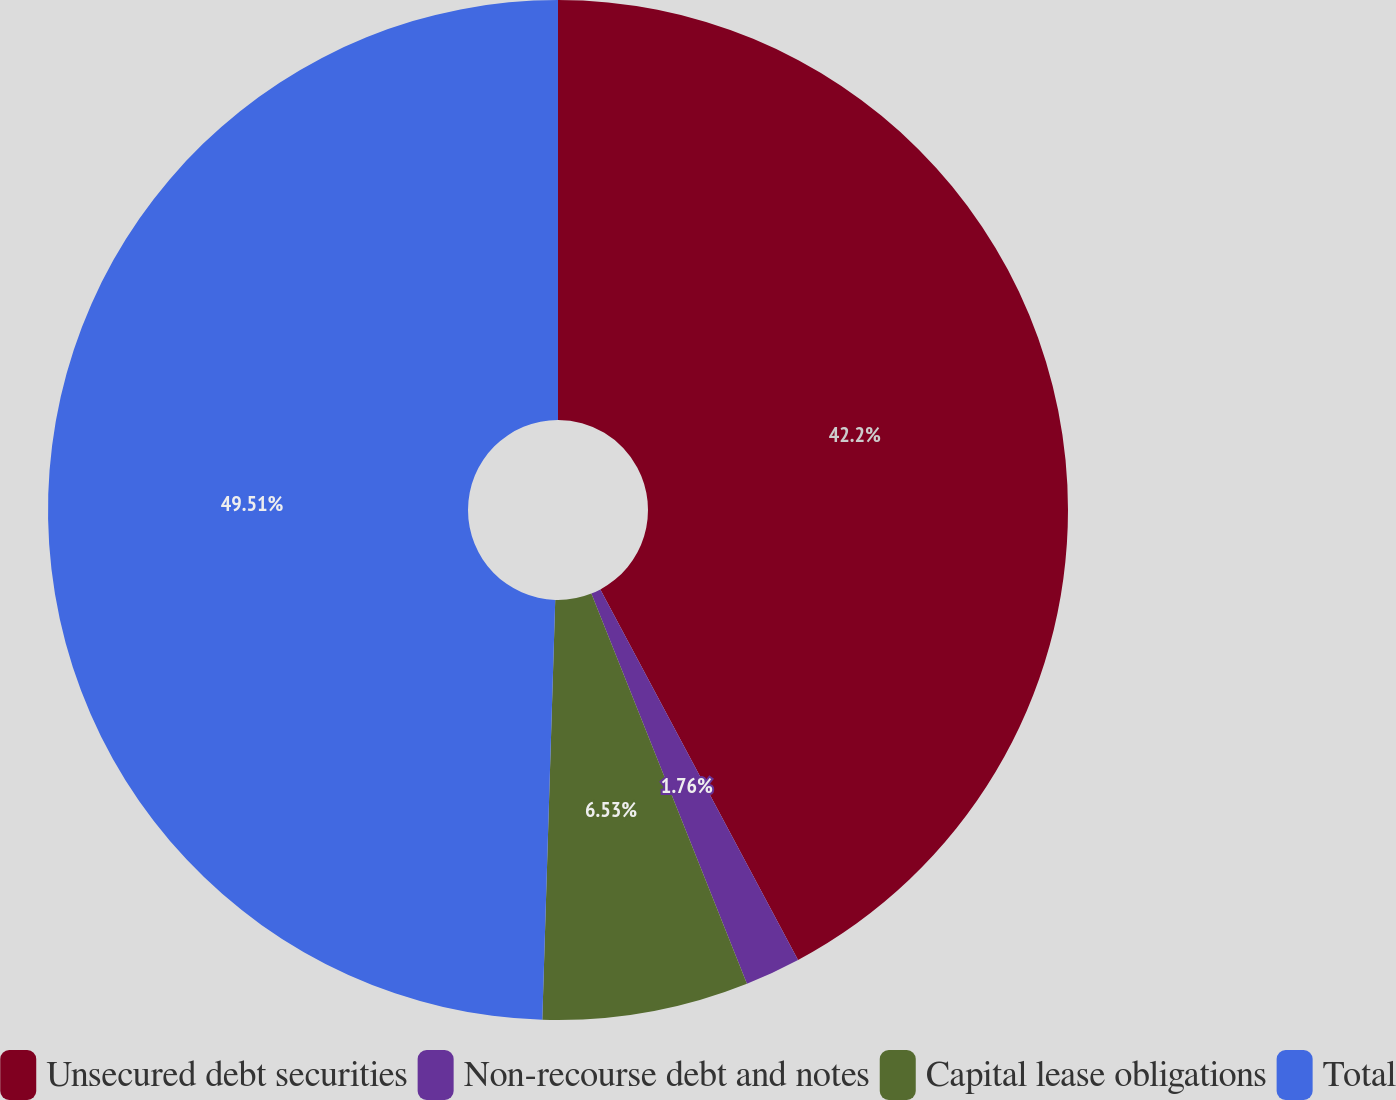Convert chart to OTSL. <chart><loc_0><loc_0><loc_500><loc_500><pie_chart><fcel>Unsecured debt securities<fcel>Non-recourse debt and notes<fcel>Capital lease obligations<fcel>Total<nl><fcel>42.2%<fcel>1.76%<fcel>6.53%<fcel>49.51%<nl></chart> 